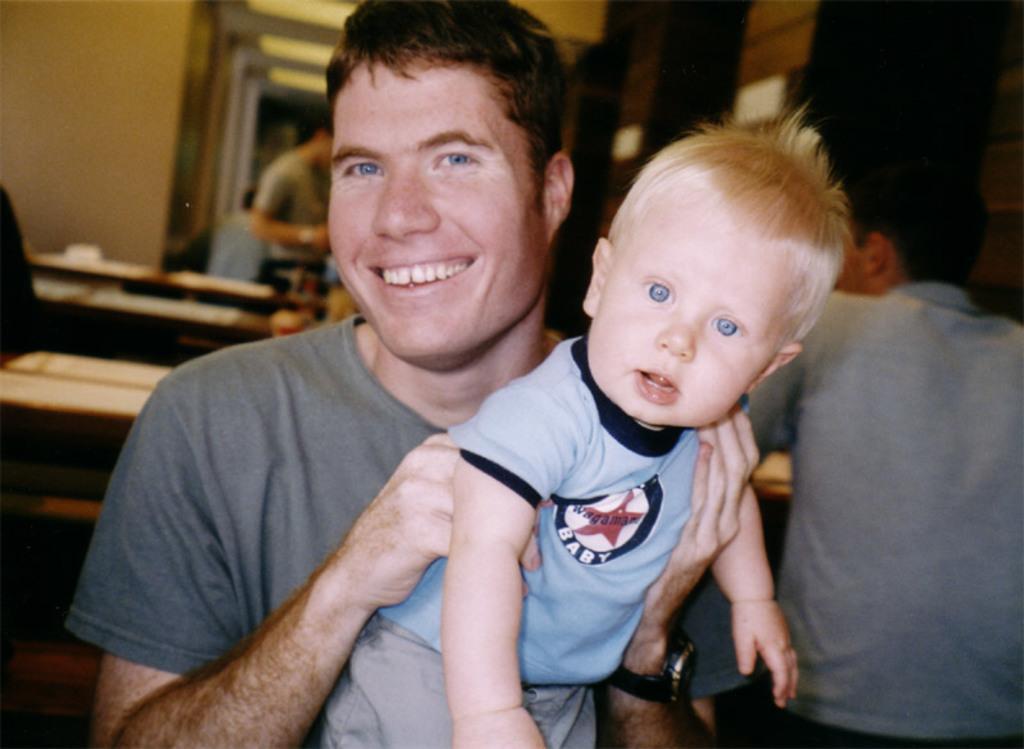How would you summarize this image in a sentence or two? In this image I can see number of people and I can see one man is holding a boy. I can also see smile on his face. On the left side of the image I can see few things and I can also see this image is little bit blurry in the background. 